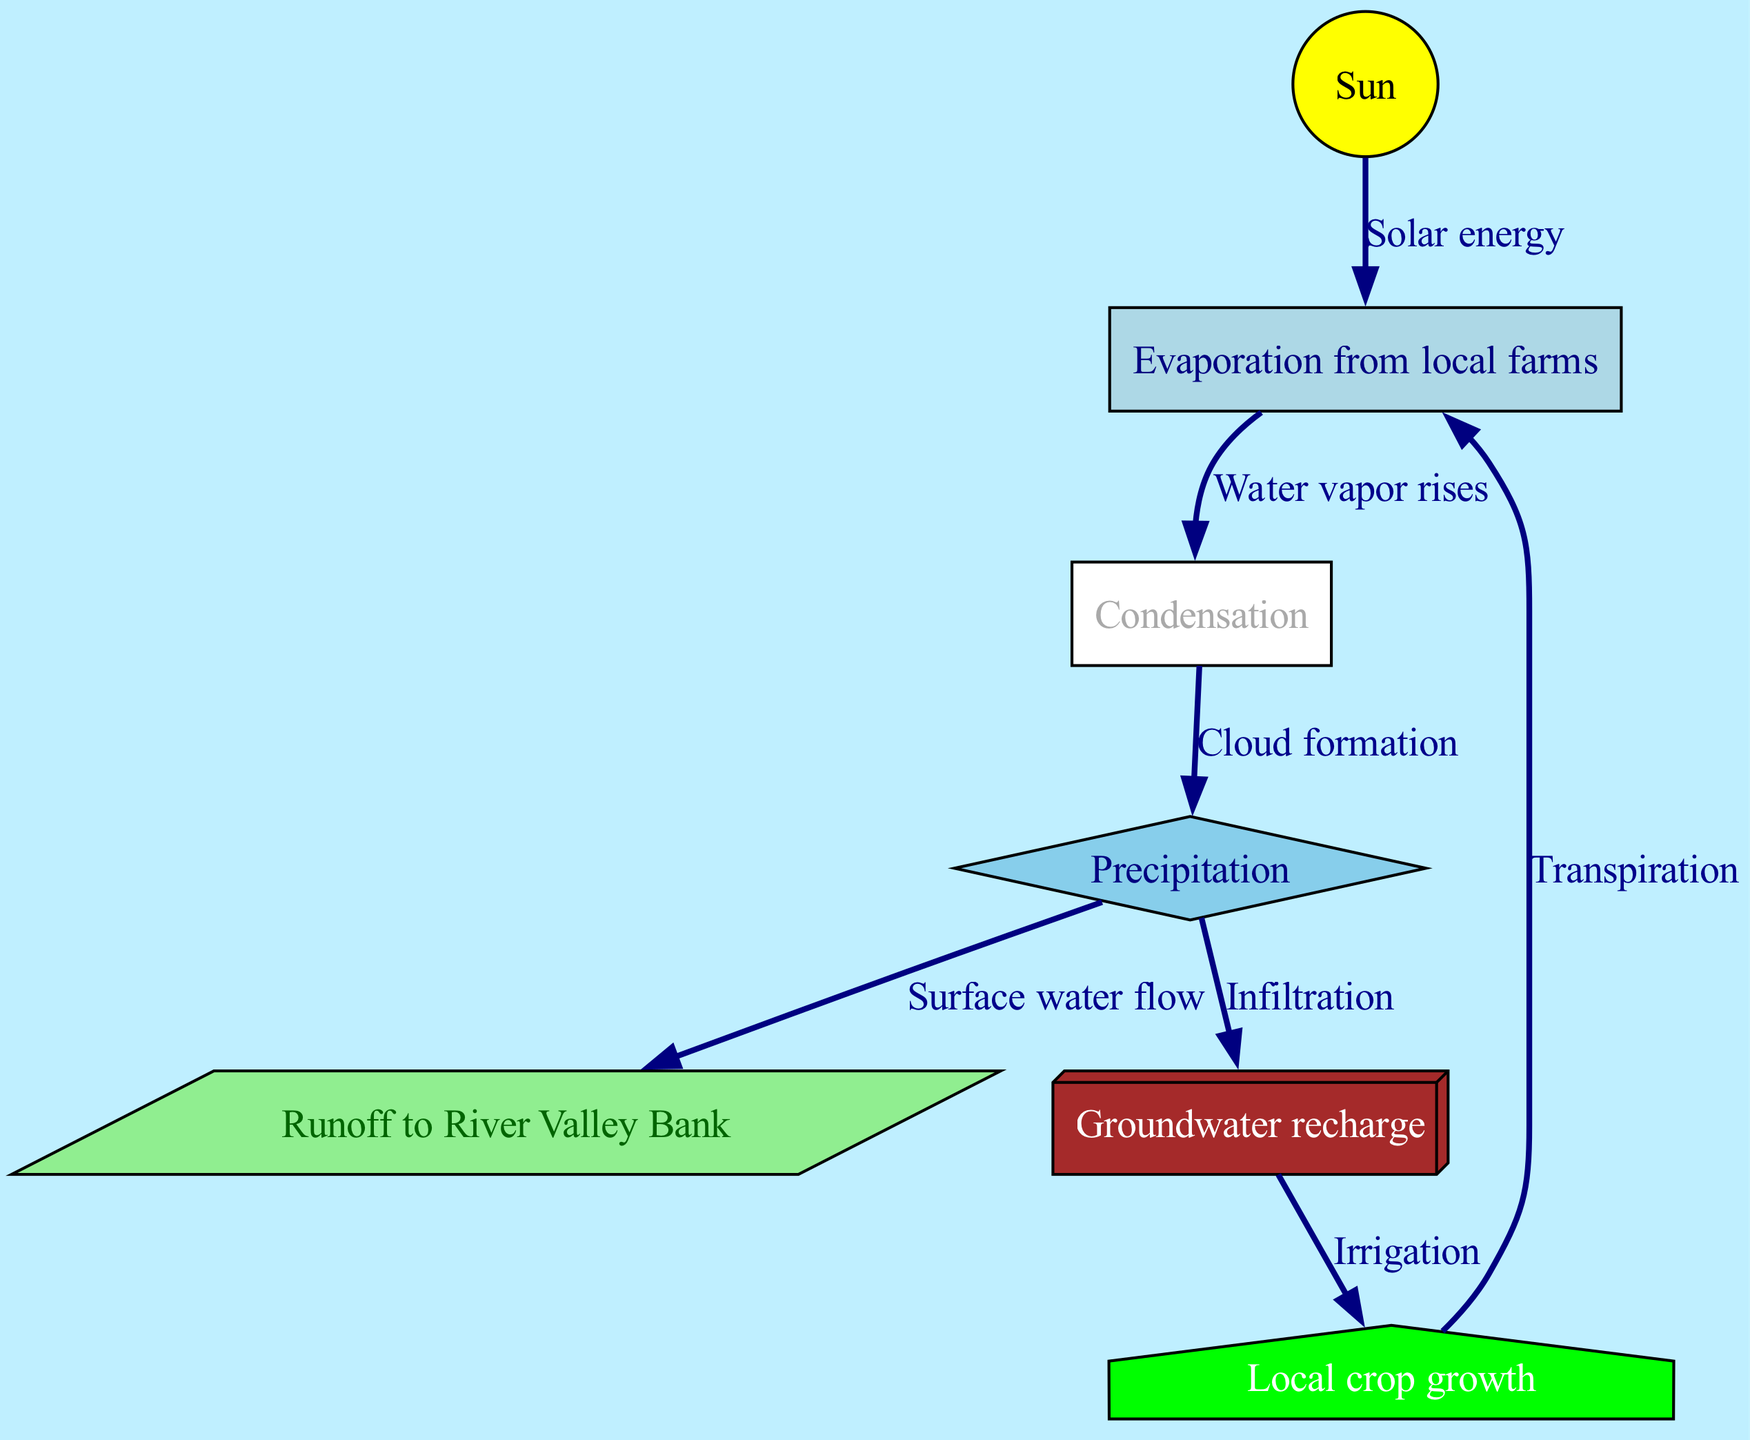What is the initial source of energy in the water cycle? The diagram shows the "Sun" as the starting node, which is labeled as the source of solar energy in the water cycle.
Answer: Sun How many nodes are present in the diagram? By counting the unique entities represented in the diagram, there are seven nodes identified.
Answer: 7 Which process directly follows condensation? The diagram indicates that condensation leads directly to "Precipitation," which is the next step after condensation.
Answer: Precipitation What happens to the water after precipitation? According to the diagram, precipitation results in "Runoff to River Valley Bank" and "Groundwater recharge," showing the dual pathways for water after it falls.
Answer: Runoff to River Valley Bank, Groundwater recharge What is the relationship between crops and evaporation? The diagram presents "Crops" which lead to "Evaporation" through the process of transpiration, indicating crops contribute to the evaporation cycle.
Answer: Transpiration How does groundwater contribute to crop growth? The diagram shows that "Groundwater recharge" integrates into the process of irrigation for "Crops," illustrating that groundwater supports their growth.
Answer: Irrigation What is the flow connection for water vapor rising? The diagram clearly indicates that "Evaporation from local farms" leads to "Condensation," making this the path for water vapor rising.
Answer: Evaporation from local farms to Condensation How does solar energy influence the water cycle? The diagram identifies "Solar energy" coming from the "Sun" and shows it directly triggering "Evaporation from local farms," indicating its essential role in the cycle.
Answer: Evaporation from local farms 